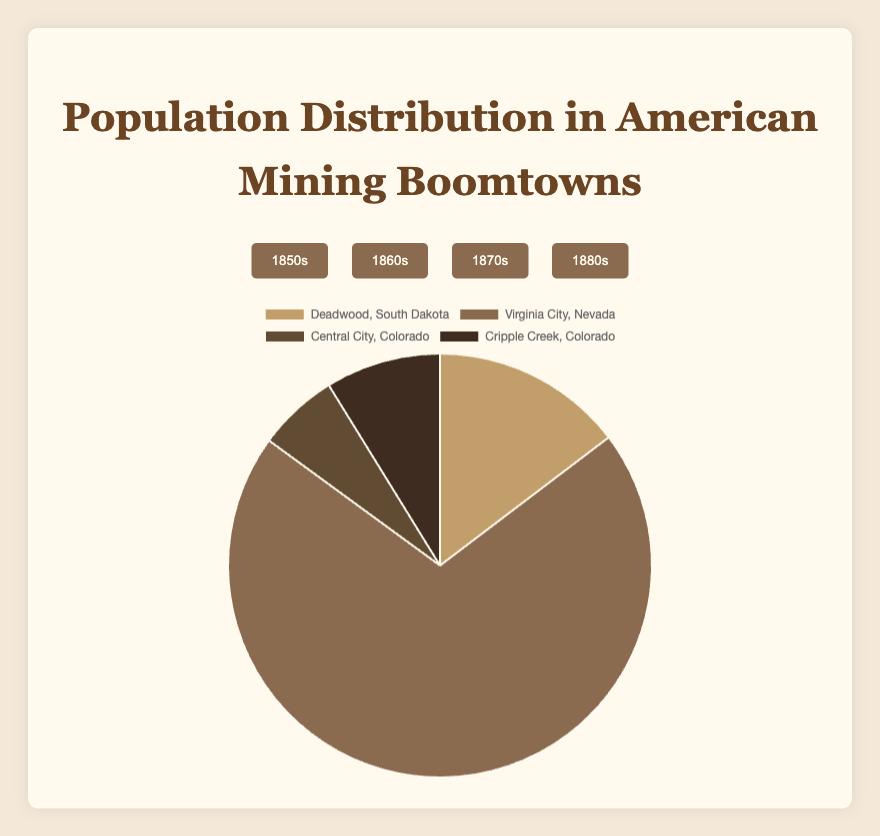Which town had the highest population in the 1850s? By looking at the pie chart for the 1850s, the town with the largest share of the chart represents the highest population. Virginia City, Nevada, dominates the chart, indicating it had the highest population.
Answer: Virginia City, Nevada How does the population of Cripple Creek, Colorado, in the 1860s compare to Deadwood, South Dakota, in the same decade? In the 1860s pie chart, observe the segments representing Cripple Creek, Colorado, and Deadwood, South Dakota. Cripple Creek had a smaller segment compared to Deadwood. This shows Cripple Creek had a lower population.
Answer: Cripple Creek had a lower population Was the population of Deadwood, South Dakota, larger in the 1870s or 1880s? Compare the chart segments for Deadwood in the 1870s and 1880s charts. The segment in the 1870s was much larger, indicating a higher population compared to the 1880s.
Answer: 1870s Which town had the smallest population in the 1850s, and what was that population? By looking at the smallest segment in the 1850s pie chart, Central City, Colorado, is the smallest. Referring to the data, its population was 2,100.
Answer: Central City, Colorado; 2,100 What is the combined population of Deadwood, South Dakota, across all four decades? Sum the populations of Deadwood from each decade: 5,000 (1850s) + 15,000 (1860s) + 25,000 (1870s) + 5,000 (1880s). The total is 50,000.
Answer: 50,000 Between the 1860s and 1870s, how did the population of Virginia City, Nevada, change? Observe the pie charts for both decades. Virginia City's segment is larger in the 1860s than in the 1870s. The population decreased from 25,000 in the 1860s to 10,000 in the 1870s.
Answer: Decreased What is the percentage difference of Central City, Colorado’s population between the 1850s and 1880s? Calculate the percentage increase from 2,100 (1850s) to 7,000 (1880s). The difference is 7,000 - 2,100 = 4,900. The percentage increase is (4,900 / 2,100) * 100 ≈ 233.3%.
Answer: 233.3% Which decade saw the highest population for Cripple Creek, Colorado? Compare the segments representing Cripple Creek across all decade charts. The largest segment appears in the 1860s, showing the highest population.
Answer: 1860s How did the population of Deadwood, South Dakota, change from the 1850s to the 1880s? Examine Deadwood's segments across the 1850s and 1880s charts. They both appear similarly sized. The population was 5,000 in both decades, showing no change.
Answer: No change If you sum the population of all towns in the 1860s, what is the total population for that decade? Add the populations of all towns in the 1860s: Deadwood (15,000), Virginia City (25,000), Central City (2,600), and Cripple Creek (8,000). The sum is 50,600.
Answer: 50,600 